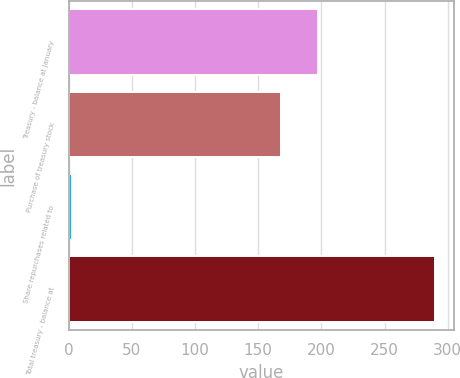Convert chart to OTSL. <chart><loc_0><loc_0><loc_500><loc_500><bar_chart><fcel>Treasury - balance at January<fcel>Purchase of treasury stock<fcel>Share repurchases related to<fcel>Total treasury - balance at<nl><fcel>196.96<fcel>168.2<fcel>2.7<fcel>290.3<nl></chart> 